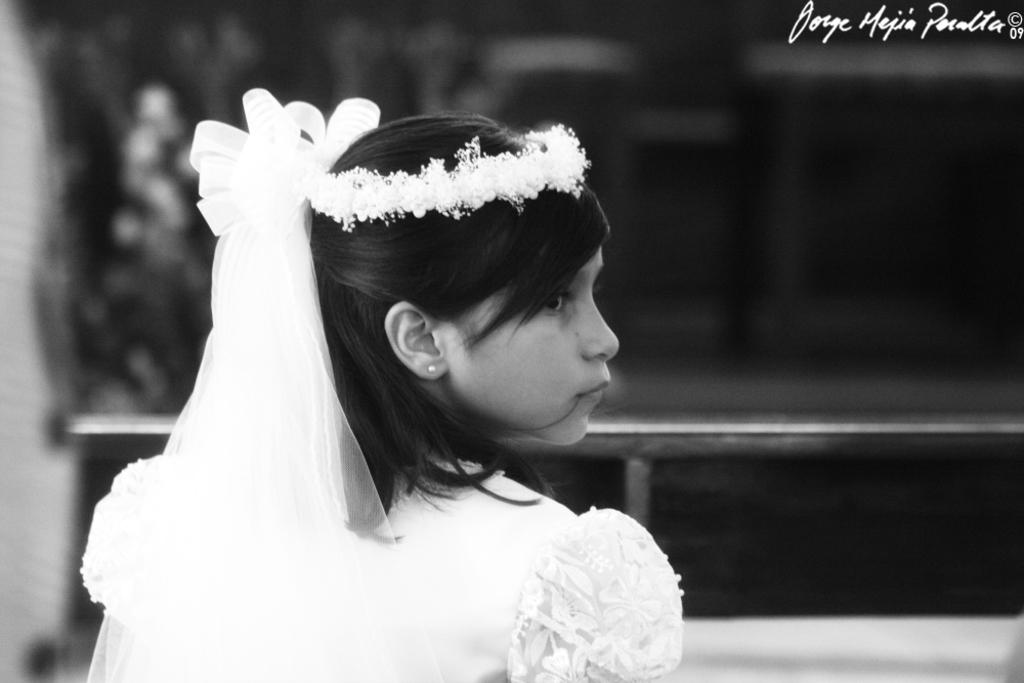What is the main subject of the image? There is a person in the image. What is the person wearing? The person is wearing a dress and a crown. Can you describe the background of the image? The background of the image is blurred. What is the color scheme of the image? The image is black and white. How many cows are sitting on the sofa in the image? There are no cows or sofa present in the image. What type of prose is being recited by the person in the image? The image is black and white and does not provide any information about the person reciting prose or the content of any prose. 